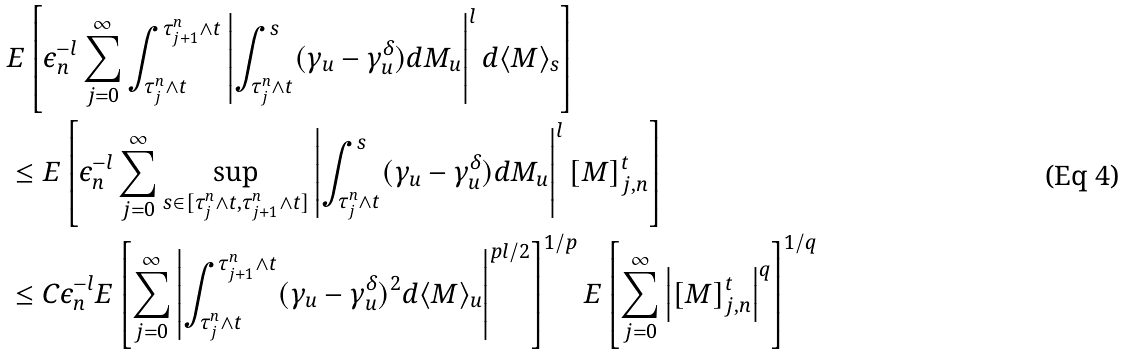<formula> <loc_0><loc_0><loc_500><loc_500>& E \left [ \epsilon _ { n } ^ { - l } \sum _ { j = 0 } ^ { \infty } \int _ { \tau ^ { n } _ { j } \wedge t } ^ { \tau ^ { n } _ { j + 1 } \wedge t } \left | \int _ { \tau ^ { n } _ { j } \wedge t } ^ { s } ( \gamma _ { u } - \gamma ^ { \delta } _ { u } ) d M _ { u } \right | ^ { l } d \langle M \rangle _ { s } \right ] \\ & \leq E \left [ \epsilon _ { n } ^ { - l } \sum _ { j = 0 } ^ { \infty } \sup _ { s \in [ \tau ^ { n } _ { j } \wedge t , \tau ^ { n } _ { j + 1 } \wedge t ] } \left | \int _ { \tau ^ { n } _ { j } \wedge t } ^ { s } ( \gamma _ { u } - \gamma ^ { \delta } _ { u } ) d M _ { u } \right | ^ { l } [ M ] _ { j , n } ^ { t } \right ] \\ & \leq C \epsilon _ { n } ^ { - l } E \left [ \sum _ { j = 0 } ^ { \infty } \left | \int _ { \tau ^ { n } _ { j } \wedge t } ^ { \tau ^ { n } _ { j + 1 } \wedge t } ( \gamma _ { u } - \gamma ^ { \delta } _ { u } ) ^ { 2 } d \langle M \rangle _ { u } \right | ^ { p l / 2 } \right ] ^ { 1 / p } E \left [ \sum _ { j = 0 } ^ { \infty } \left | [ M ] _ { j , n } ^ { t } \right | ^ { q } \right ] ^ { 1 / q }</formula> 